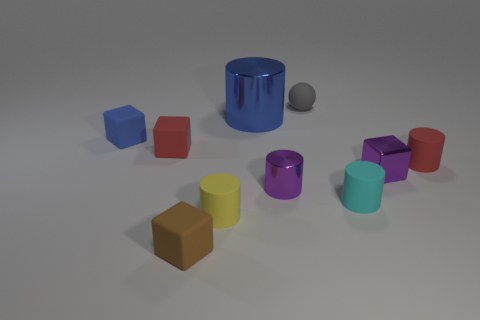Subtract all cyan cylinders. How many cylinders are left? 4 Subtract 1 blocks. How many blocks are left? 3 Subtract all small red cylinders. How many cylinders are left? 4 Subtract all green cylinders. Subtract all cyan spheres. How many cylinders are left? 5 Subtract all spheres. How many objects are left? 9 Subtract 1 yellow cylinders. How many objects are left? 9 Subtract all yellow spheres. Subtract all small shiny cylinders. How many objects are left? 9 Add 4 cyan objects. How many cyan objects are left? 5 Add 7 red objects. How many red objects exist? 9 